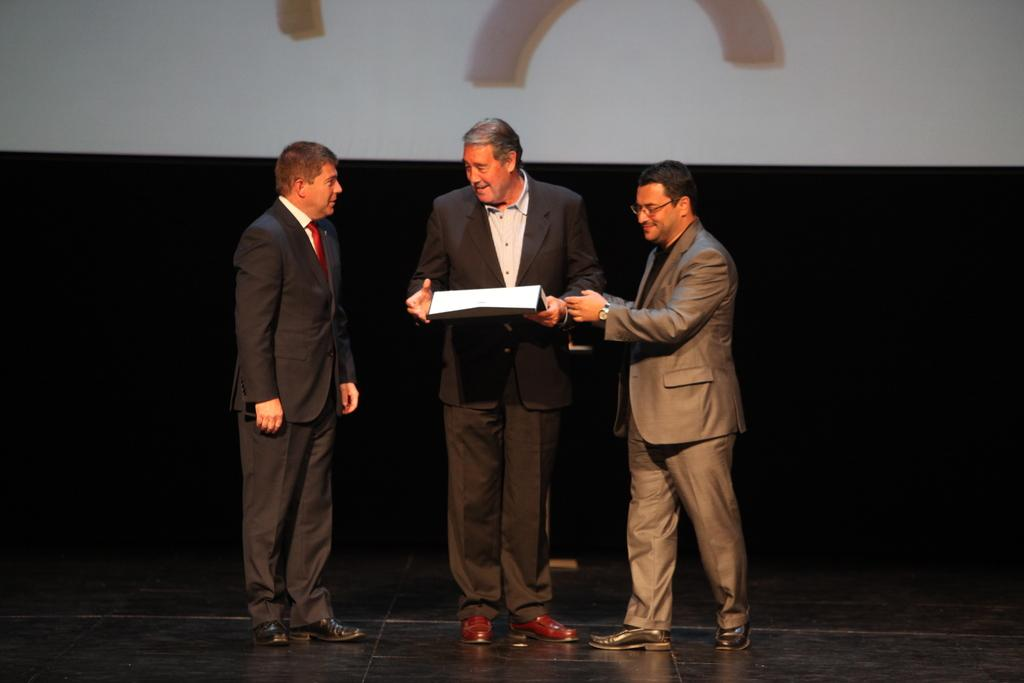How many people are present in the image? There are three persons standing in the center of the image. What is one person holding in the image? One person is holding a paper. What can be seen in the background of the image? There is a screen and a curtain in the background of the image. What part of the room is visible at the bottom of the image? The floor is visible at the bottom of the image. What type of net can be seen hanging from the ceiling in the image? There is no net present in the image; it only features three persons, a paper, a screen, a curtain, and the floor. 